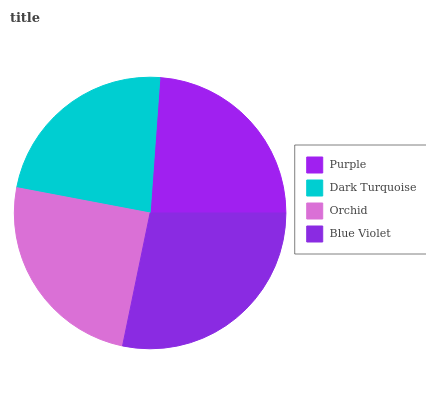Is Dark Turquoise the minimum?
Answer yes or no. Yes. Is Blue Violet the maximum?
Answer yes or no. Yes. Is Orchid the minimum?
Answer yes or no. No. Is Orchid the maximum?
Answer yes or no. No. Is Orchid greater than Dark Turquoise?
Answer yes or no. Yes. Is Dark Turquoise less than Orchid?
Answer yes or no. Yes. Is Dark Turquoise greater than Orchid?
Answer yes or no. No. Is Orchid less than Dark Turquoise?
Answer yes or no. No. Is Orchid the high median?
Answer yes or no. Yes. Is Purple the low median?
Answer yes or no. Yes. Is Purple the high median?
Answer yes or no. No. Is Blue Violet the low median?
Answer yes or no. No. 